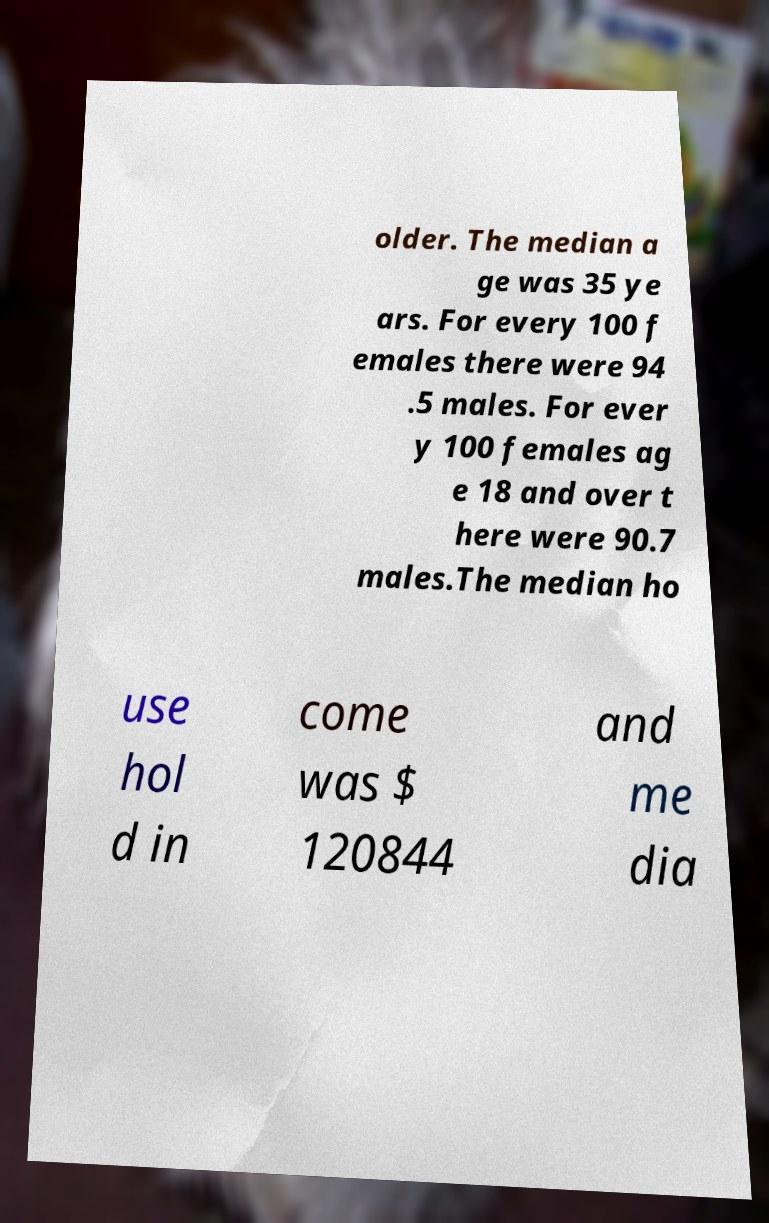I need the written content from this picture converted into text. Can you do that? older. The median a ge was 35 ye ars. For every 100 f emales there were 94 .5 males. For ever y 100 females ag e 18 and over t here were 90.7 males.The median ho use hol d in come was $ 120844 and me dia 